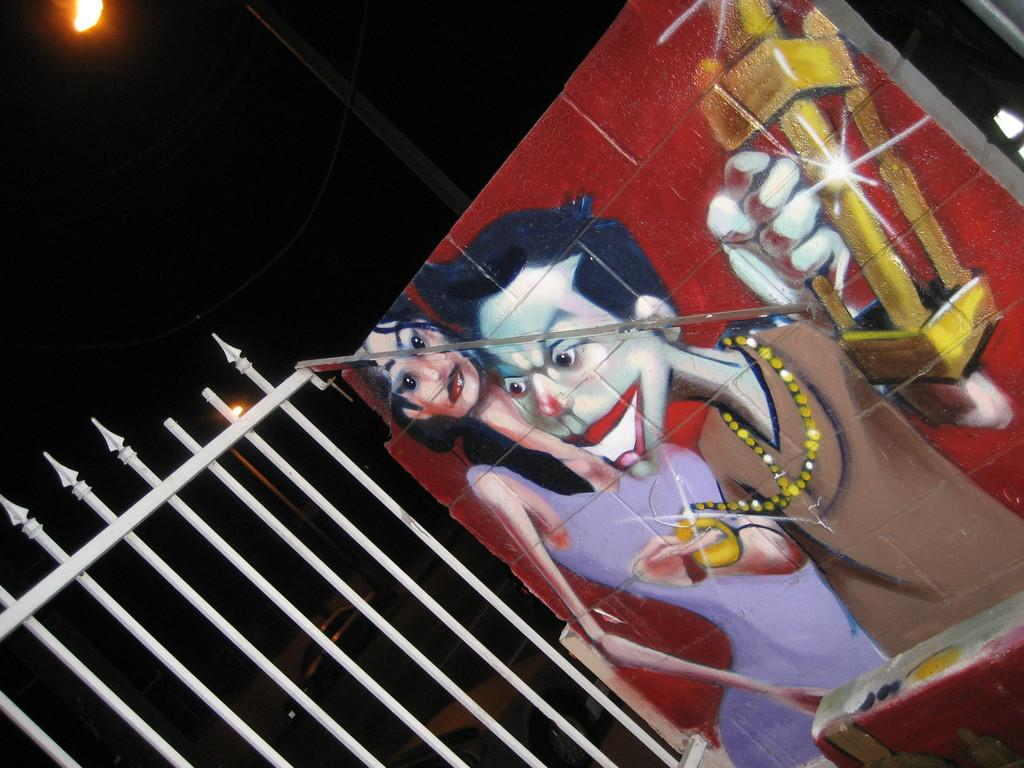What is the main subject of the image? There is a painting on a platform in the image. What structures can be seen in the image? There is a fence and a pole in the image. What is happening in the background of the image? The background of the image is dark. What can be seen on the road in the image? There are cars on the road in the image. Is there any source of light visible in the image? Yes, there is a light visible in the image. What type of instrument is being played by the babies in the image? There are no babies or instruments present in the image. 